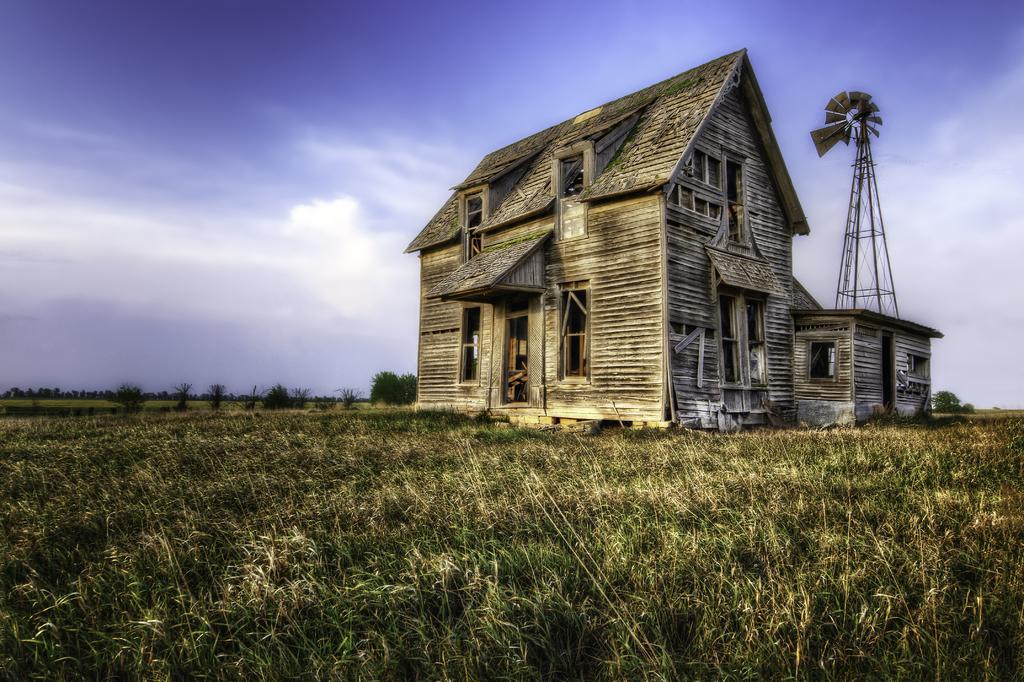What type of house is in the image? There is a wooden house in the image. Where is the house situated in relation to the field? The house is located between a field. What is behind the house in the image? There is a tower behind the house. What can be seen near the tower? A fan is present near the tower. What is visible in the background of the image? The sky is visible in the background of the image. What design is featured on the cast of the person in the image? There is no person or cast present in the image; it features a wooden house, a tower, a fan, and the sky. 